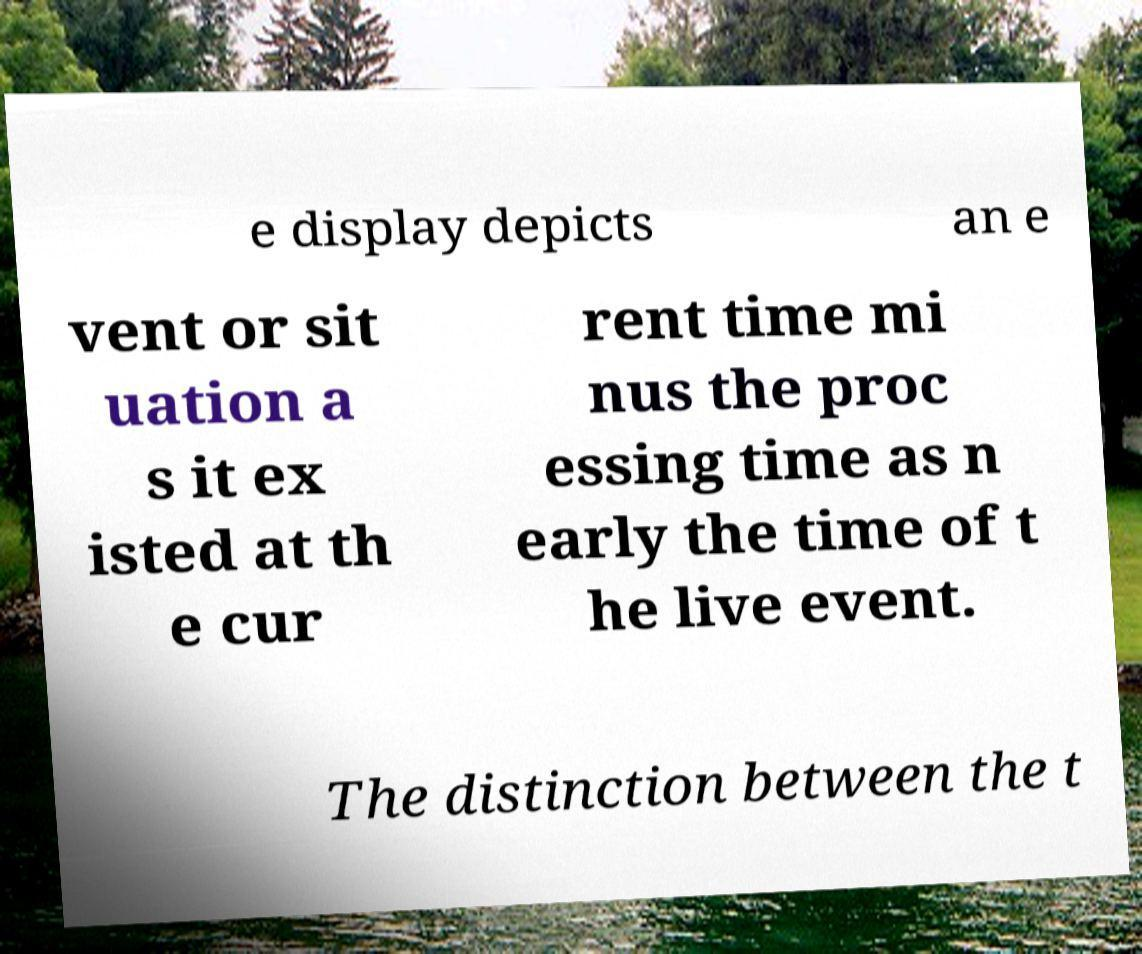Can you read and provide the text displayed in the image?This photo seems to have some interesting text. Can you extract and type it out for me? e display depicts an e vent or sit uation a s it ex isted at th e cur rent time mi nus the proc essing time as n early the time of t he live event. The distinction between the t 